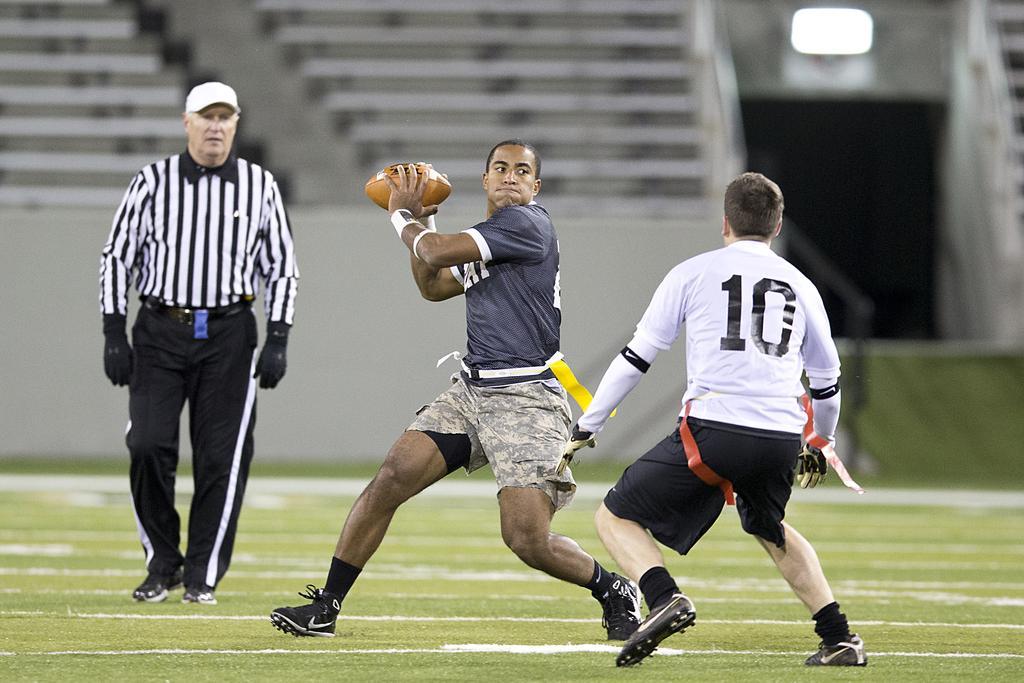Could you give a brief overview of what you see in this image? there are three persons in a ground two persons are playing with a ball and one person is walking 